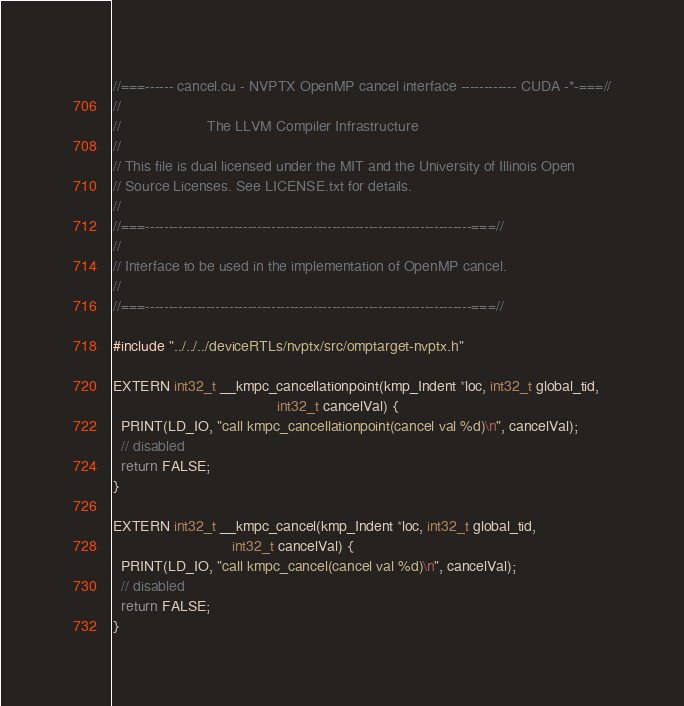<code> <loc_0><loc_0><loc_500><loc_500><_Cuda_>//===------ cancel.cu - NVPTX OpenMP cancel interface ------------ CUDA -*-===//
//
//                     The LLVM Compiler Infrastructure
//
// This file is dual licensed under the MIT and the University of Illinois Open
// Source Licenses. See LICENSE.txt for details.
//
//===----------------------------------------------------------------------===//
//
// Interface to be used in the implementation of OpenMP cancel.
//
//===----------------------------------------------------------------------===//

#include "../../../deviceRTLs/nvptx/src/omptarget-nvptx.h"

EXTERN int32_t __kmpc_cancellationpoint(kmp_Indent *loc, int32_t global_tid,
                                        int32_t cancelVal) {
  PRINT(LD_IO, "call kmpc_cancellationpoint(cancel val %d)\n", cancelVal);
  // disabled
  return FALSE;
}

EXTERN int32_t __kmpc_cancel(kmp_Indent *loc, int32_t global_tid,
                             int32_t cancelVal) {
  PRINT(LD_IO, "call kmpc_cancel(cancel val %d)\n", cancelVal);
  // disabled
  return FALSE;
}
</code> 